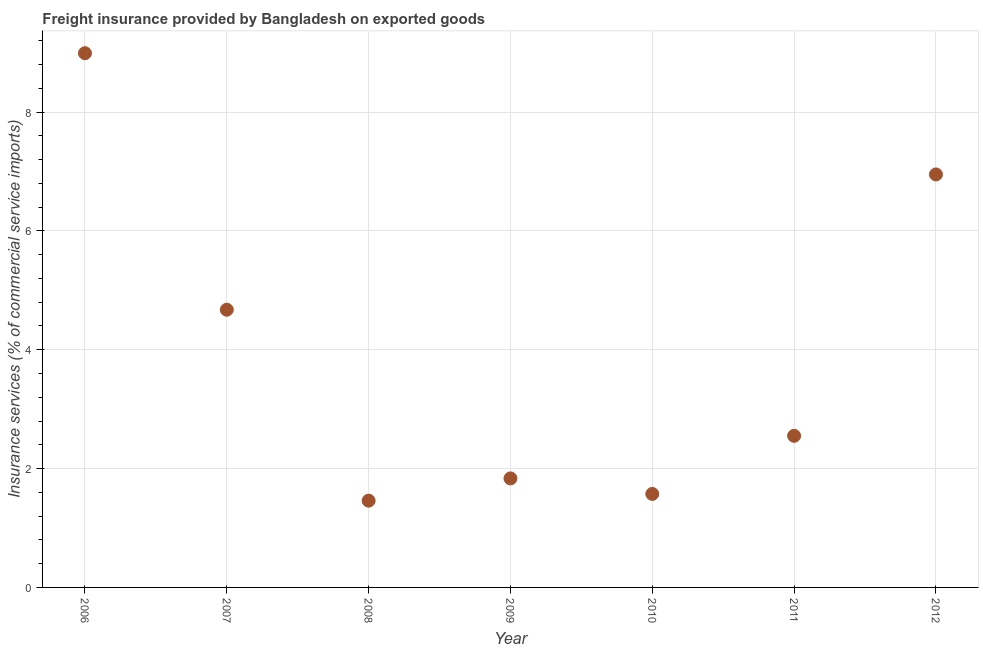What is the freight insurance in 2011?
Ensure brevity in your answer.  2.55. Across all years, what is the maximum freight insurance?
Your answer should be compact. 8.99. Across all years, what is the minimum freight insurance?
Your answer should be very brief. 1.46. In which year was the freight insurance maximum?
Your answer should be very brief. 2006. What is the sum of the freight insurance?
Your answer should be compact. 28.03. What is the difference between the freight insurance in 2006 and 2007?
Keep it short and to the point. 4.32. What is the average freight insurance per year?
Ensure brevity in your answer.  4. What is the median freight insurance?
Offer a very short reply. 2.55. In how many years, is the freight insurance greater than 8 %?
Your answer should be very brief. 1. Do a majority of the years between 2012 and 2010 (inclusive) have freight insurance greater than 4 %?
Offer a very short reply. No. What is the ratio of the freight insurance in 2006 to that in 2009?
Offer a very short reply. 4.9. What is the difference between the highest and the second highest freight insurance?
Ensure brevity in your answer.  2.04. Is the sum of the freight insurance in 2008 and 2011 greater than the maximum freight insurance across all years?
Make the answer very short. No. What is the difference between the highest and the lowest freight insurance?
Make the answer very short. 7.53. Does the freight insurance monotonically increase over the years?
Keep it short and to the point. No. How many years are there in the graph?
Provide a succinct answer. 7. What is the title of the graph?
Keep it short and to the point. Freight insurance provided by Bangladesh on exported goods . What is the label or title of the X-axis?
Your answer should be very brief. Year. What is the label or title of the Y-axis?
Provide a short and direct response. Insurance services (% of commercial service imports). What is the Insurance services (% of commercial service imports) in 2006?
Your answer should be compact. 8.99. What is the Insurance services (% of commercial service imports) in 2007?
Your response must be concise. 4.67. What is the Insurance services (% of commercial service imports) in 2008?
Give a very brief answer. 1.46. What is the Insurance services (% of commercial service imports) in 2009?
Offer a terse response. 1.83. What is the Insurance services (% of commercial service imports) in 2010?
Offer a terse response. 1.57. What is the Insurance services (% of commercial service imports) in 2011?
Your answer should be compact. 2.55. What is the Insurance services (% of commercial service imports) in 2012?
Offer a terse response. 6.95. What is the difference between the Insurance services (% of commercial service imports) in 2006 and 2007?
Offer a very short reply. 4.32. What is the difference between the Insurance services (% of commercial service imports) in 2006 and 2008?
Your response must be concise. 7.53. What is the difference between the Insurance services (% of commercial service imports) in 2006 and 2009?
Provide a short and direct response. 7.16. What is the difference between the Insurance services (% of commercial service imports) in 2006 and 2010?
Your response must be concise. 7.42. What is the difference between the Insurance services (% of commercial service imports) in 2006 and 2011?
Provide a succinct answer. 6.44. What is the difference between the Insurance services (% of commercial service imports) in 2006 and 2012?
Give a very brief answer. 2.04. What is the difference between the Insurance services (% of commercial service imports) in 2007 and 2008?
Give a very brief answer. 3.21. What is the difference between the Insurance services (% of commercial service imports) in 2007 and 2009?
Ensure brevity in your answer.  2.84. What is the difference between the Insurance services (% of commercial service imports) in 2007 and 2010?
Ensure brevity in your answer.  3.1. What is the difference between the Insurance services (% of commercial service imports) in 2007 and 2011?
Give a very brief answer. 2.12. What is the difference between the Insurance services (% of commercial service imports) in 2007 and 2012?
Keep it short and to the point. -2.28. What is the difference between the Insurance services (% of commercial service imports) in 2008 and 2009?
Provide a short and direct response. -0.37. What is the difference between the Insurance services (% of commercial service imports) in 2008 and 2010?
Provide a succinct answer. -0.11. What is the difference between the Insurance services (% of commercial service imports) in 2008 and 2011?
Your response must be concise. -1.09. What is the difference between the Insurance services (% of commercial service imports) in 2008 and 2012?
Your answer should be compact. -5.49. What is the difference between the Insurance services (% of commercial service imports) in 2009 and 2010?
Keep it short and to the point. 0.26. What is the difference between the Insurance services (% of commercial service imports) in 2009 and 2011?
Provide a short and direct response. -0.72. What is the difference between the Insurance services (% of commercial service imports) in 2009 and 2012?
Give a very brief answer. -5.12. What is the difference between the Insurance services (% of commercial service imports) in 2010 and 2011?
Keep it short and to the point. -0.98. What is the difference between the Insurance services (% of commercial service imports) in 2010 and 2012?
Provide a succinct answer. -5.38. What is the difference between the Insurance services (% of commercial service imports) in 2011 and 2012?
Make the answer very short. -4.4. What is the ratio of the Insurance services (% of commercial service imports) in 2006 to that in 2007?
Give a very brief answer. 1.92. What is the ratio of the Insurance services (% of commercial service imports) in 2006 to that in 2008?
Your response must be concise. 6.16. What is the ratio of the Insurance services (% of commercial service imports) in 2006 to that in 2010?
Your answer should be compact. 5.71. What is the ratio of the Insurance services (% of commercial service imports) in 2006 to that in 2011?
Provide a succinct answer. 3.52. What is the ratio of the Insurance services (% of commercial service imports) in 2006 to that in 2012?
Ensure brevity in your answer.  1.29. What is the ratio of the Insurance services (% of commercial service imports) in 2007 to that in 2008?
Ensure brevity in your answer.  3.2. What is the ratio of the Insurance services (% of commercial service imports) in 2007 to that in 2009?
Your answer should be compact. 2.55. What is the ratio of the Insurance services (% of commercial service imports) in 2007 to that in 2010?
Provide a short and direct response. 2.97. What is the ratio of the Insurance services (% of commercial service imports) in 2007 to that in 2011?
Offer a terse response. 1.83. What is the ratio of the Insurance services (% of commercial service imports) in 2007 to that in 2012?
Your answer should be compact. 0.67. What is the ratio of the Insurance services (% of commercial service imports) in 2008 to that in 2009?
Offer a very short reply. 0.8. What is the ratio of the Insurance services (% of commercial service imports) in 2008 to that in 2010?
Ensure brevity in your answer.  0.93. What is the ratio of the Insurance services (% of commercial service imports) in 2008 to that in 2011?
Ensure brevity in your answer.  0.57. What is the ratio of the Insurance services (% of commercial service imports) in 2008 to that in 2012?
Give a very brief answer. 0.21. What is the ratio of the Insurance services (% of commercial service imports) in 2009 to that in 2010?
Provide a short and direct response. 1.17. What is the ratio of the Insurance services (% of commercial service imports) in 2009 to that in 2011?
Your answer should be compact. 0.72. What is the ratio of the Insurance services (% of commercial service imports) in 2009 to that in 2012?
Provide a succinct answer. 0.26. What is the ratio of the Insurance services (% of commercial service imports) in 2010 to that in 2011?
Offer a very short reply. 0.62. What is the ratio of the Insurance services (% of commercial service imports) in 2010 to that in 2012?
Make the answer very short. 0.23. What is the ratio of the Insurance services (% of commercial service imports) in 2011 to that in 2012?
Ensure brevity in your answer.  0.37. 